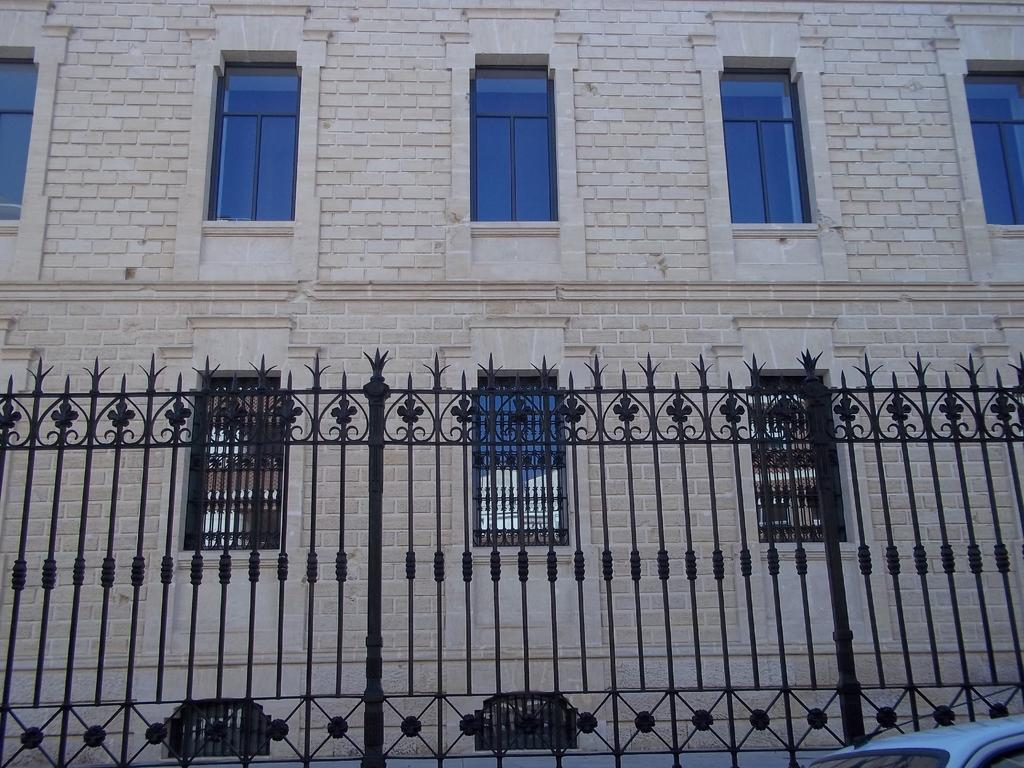What type of structure can be seen in the image? There is a fencing in the image. What is located behind the fencing? There is a big building behind the fencing. What features can be observed on the building? The building has windows and glasses. What type of bell can be heard ringing in the image? There is no bell present in the image, and therefore no sound can be heard. 